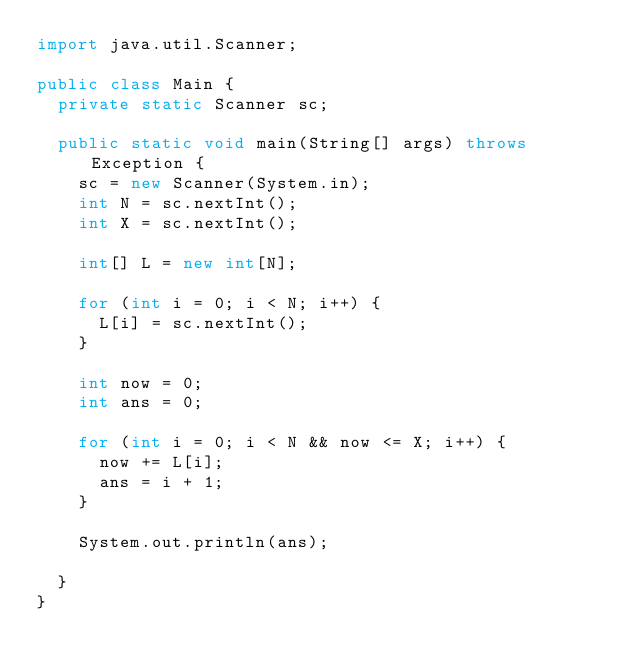Convert code to text. <code><loc_0><loc_0><loc_500><loc_500><_Java_>import java.util.Scanner;

public class Main {
	private static Scanner sc;

	public static void main(String[] args) throws Exception {
		sc = new Scanner(System.in);
		int N = sc.nextInt();
		int X = sc.nextInt();

		int[] L = new int[N];

		for (int i = 0; i < N; i++) {
			L[i] = sc.nextInt();
		}

		int now = 0;
		int ans = 0;

		for (int i = 0; i < N && now <= X; i++) {
			now += L[i];
			ans = i + 1;
		}

		System.out.println(ans);

	}
}
</code> 